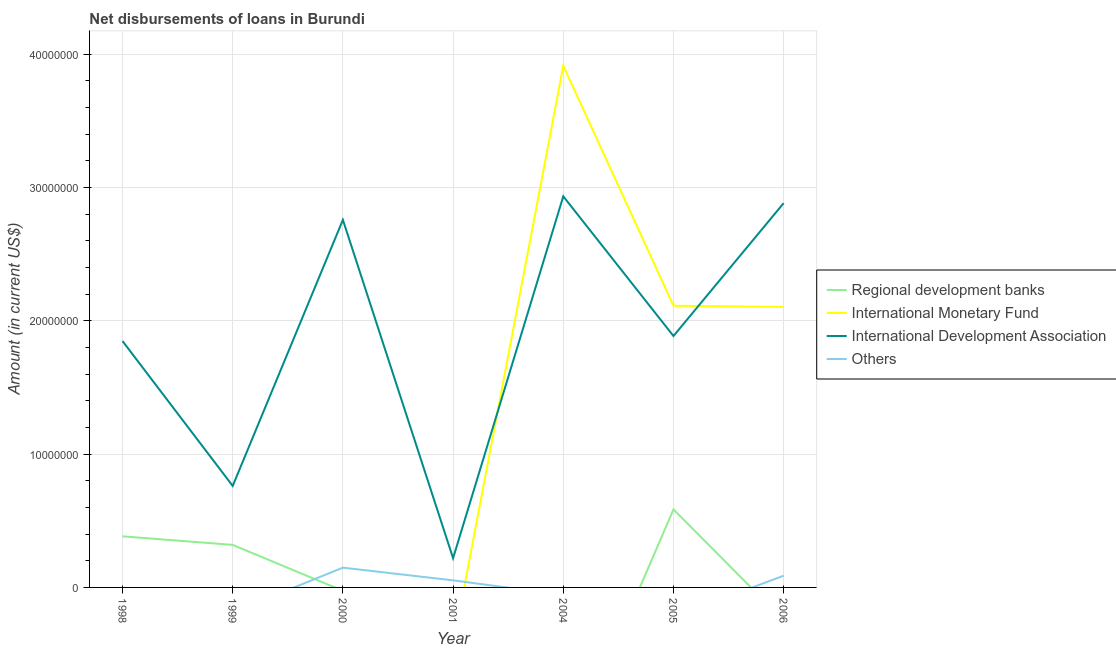How many different coloured lines are there?
Keep it short and to the point. 4. Across all years, what is the maximum amount of loan disimbursed by international monetary fund?
Your answer should be compact. 3.91e+07. Across all years, what is the minimum amount of loan disimbursed by international development association?
Give a very brief answer. 2.19e+06. What is the total amount of loan disimbursed by regional development banks in the graph?
Keep it short and to the point. 1.29e+07. What is the difference between the amount of loan disimbursed by international development association in 2005 and that in 2006?
Keep it short and to the point. -9.97e+06. What is the average amount of loan disimbursed by regional development banks per year?
Keep it short and to the point. 1.84e+06. In the year 1999, what is the difference between the amount of loan disimbursed by regional development banks and amount of loan disimbursed by international development association?
Your answer should be compact. -4.42e+06. In how many years, is the amount of loan disimbursed by other organisations greater than 12000000 US$?
Give a very brief answer. 0. What is the ratio of the amount of loan disimbursed by international development association in 1998 to that in 1999?
Provide a succinct answer. 2.43. What is the difference between the highest and the second highest amount of loan disimbursed by regional development banks?
Your response must be concise. 2.02e+06. What is the difference between the highest and the lowest amount of loan disimbursed by regional development banks?
Offer a terse response. 5.85e+06. Is it the case that in every year, the sum of the amount of loan disimbursed by regional development banks and amount of loan disimbursed by international monetary fund is greater than the amount of loan disimbursed by international development association?
Provide a succinct answer. No. Does the amount of loan disimbursed by regional development banks monotonically increase over the years?
Ensure brevity in your answer.  No. How many years are there in the graph?
Keep it short and to the point. 7. What is the difference between two consecutive major ticks on the Y-axis?
Ensure brevity in your answer.  1.00e+07. Does the graph contain any zero values?
Offer a terse response. Yes. How many legend labels are there?
Offer a terse response. 4. What is the title of the graph?
Your answer should be compact. Net disbursements of loans in Burundi. Does "Compensation of employees" appear as one of the legend labels in the graph?
Keep it short and to the point. No. What is the label or title of the Y-axis?
Ensure brevity in your answer.  Amount (in current US$). What is the Amount (in current US$) of Regional development banks in 1998?
Your response must be concise. 3.83e+06. What is the Amount (in current US$) in International Monetary Fund in 1998?
Your answer should be very brief. 0. What is the Amount (in current US$) in International Development Association in 1998?
Provide a short and direct response. 1.85e+07. What is the Amount (in current US$) in Others in 1998?
Your response must be concise. 0. What is the Amount (in current US$) in Regional development banks in 1999?
Keep it short and to the point. 3.19e+06. What is the Amount (in current US$) in International Monetary Fund in 1999?
Provide a short and direct response. 0. What is the Amount (in current US$) in International Development Association in 1999?
Keep it short and to the point. 7.61e+06. What is the Amount (in current US$) in Others in 1999?
Make the answer very short. 0. What is the Amount (in current US$) in Regional development banks in 2000?
Your answer should be very brief. 0. What is the Amount (in current US$) of International Monetary Fund in 2000?
Give a very brief answer. 0. What is the Amount (in current US$) in International Development Association in 2000?
Make the answer very short. 2.76e+07. What is the Amount (in current US$) of Others in 2000?
Provide a succinct answer. 1.48e+06. What is the Amount (in current US$) in International Monetary Fund in 2001?
Your answer should be compact. 0. What is the Amount (in current US$) in International Development Association in 2001?
Offer a very short reply. 2.19e+06. What is the Amount (in current US$) in Others in 2001?
Your answer should be compact. 5.31e+05. What is the Amount (in current US$) in Regional development banks in 2004?
Your answer should be compact. 0. What is the Amount (in current US$) in International Monetary Fund in 2004?
Provide a succinct answer. 3.91e+07. What is the Amount (in current US$) of International Development Association in 2004?
Make the answer very short. 2.93e+07. What is the Amount (in current US$) of Others in 2004?
Offer a very short reply. 0. What is the Amount (in current US$) of Regional development banks in 2005?
Make the answer very short. 5.85e+06. What is the Amount (in current US$) of International Monetary Fund in 2005?
Make the answer very short. 2.11e+07. What is the Amount (in current US$) of International Development Association in 2005?
Your answer should be very brief. 1.89e+07. What is the Amount (in current US$) of Regional development banks in 2006?
Provide a succinct answer. 0. What is the Amount (in current US$) in International Monetary Fund in 2006?
Keep it short and to the point. 2.10e+07. What is the Amount (in current US$) in International Development Association in 2006?
Provide a succinct answer. 2.88e+07. What is the Amount (in current US$) of Others in 2006?
Provide a short and direct response. 8.80e+05. Across all years, what is the maximum Amount (in current US$) of Regional development banks?
Your answer should be compact. 5.85e+06. Across all years, what is the maximum Amount (in current US$) in International Monetary Fund?
Your answer should be very brief. 3.91e+07. Across all years, what is the maximum Amount (in current US$) of International Development Association?
Provide a short and direct response. 2.93e+07. Across all years, what is the maximum Amount (in current US$) in Others?
Give a very brief answer. 1.48e+06. Across all years, what is the minimum Amount (in current US$) of Regional development banks?
Ensure brevity in your answer.  0. Across all years, what is the minimum Amount (in current US$) in International Monetary Fund?
Keep it short and to the point. 0. Across all years, what is the minimum Amount (in current US$) in International Development Association?
Provide a succinct answer. 2.19e+06. What is the total Amount (in current US$) of Regional development banks in the graph?
Provide a short and direct response. 1.29e+07. What is the total Amount (in current US$) of International Monetary Fund in the graph?
Give a very brief answer. 8.13e+07. What is the total Amount (in current US$) of International Development Association in the graph?
Give a very brief answer. 1.33e+08. What is the total Amount (in current US$) in Others in the graph?
Keep it short and to the point. 2.89e+06. What is the difference between the Amount (in current US$) in Regional development banks in 1998 and that in 1999?
Keep it short and to the point. 6.42e+05. What is the difference between the Amount (in current US$) in International Development Association in 1998 and that in 1999?
Your response must be concise. 1.09e+07. What is the difference between the Amount (in current US$) in International Development Association in 1998 and that in 2000?
Ensure brevity in your answer.  -9.09e+06. What is the difference between the Amount (in current US$) of International Development Association in 1998 and that in 2001?
Make the answer very short. 1.63e+07. What is the difference between the Amount (in current US$) of International Development Association in 1998 and that in 2004?
Give a very brief answer. -1.09e+07. What is the difference between the Amount (in current US$) in Regional development banks in 1998 and that in 2005?
Give a very brief answer. -2.02e+06. What is the difference between the Amount (in current US$) in International Development Association in 1998 and that in 2005?
Give a very brief answer. -3.78e+05. What is the difference between the Amount (in current US$) in International Development Association in 1998 and that in 2006?
Your answer should be very brief. -1.03e+07. What is the difference between the Amount (in current US$) of International Development Association in 1999 and that in 2000?
Provide a succinct answer. -2.00e+07. What is the difference between the Amount (in current US$) in International Development Association in 1999 and that in 2001?
Offer a terse response. 5.42e+06. What is the difference between the Amount (in current US$) in International Development Association in 1999 and that in 2004?
Keep it short and to the point. -2.17e+07. What is the difference between the Amount (in current US$) in Regional development banks in 1999 and that in 2005?
Keep it short and to the point. -2.66e+06. What is the difference between the Amount (in current US$) of International Development Association in 1999 and that in 2005?
Offer a terse response. -1.12e+07. What is the difference between the Amount (in current US$) of International Development Association in 1999 and that in 2006?
Offer a very short reply. -2.12e+07. What is the difference between the Amount (in current US$) of International Development Association in 2000 and that in 2001?
Your answer should be very brief. 2.54e+07. What is the difference between the Amount (in current US$) of Others in 2000 and that in 2001?
Give a very brief answer. 9.51e+05. What is the difference between the Amount (in current US$) in International Development Association in 2000 and that in 2004?
Offer a very short reply. -1.76e+06. What is the difference between the Amount (in current US$) in International Development Association in 2000 and that in 2005?
Your answer should be very brief. 8.71e+06. What is the difference between the Amount (in current US$) of International Development Association in 2000 and that in 2006?
Provide a succinct answer. -1.25e+06. What is the difference between the Amount (in current US$) in Others in 2000 and that in 2006?
Your answer should be very brief. 6.02e+05. What is the difference between the Amount (in current US$) of International Development Association in 2001 and that in 2004?
Offer a terse response. -2.71e+07. What is the difference between the Amount (in current US$) in International Development Association in 2001 and that in 2005?
Ensure brevity in your answer.  -1.67e+07. What is the difference between the Amount (in current US$) of International Development Association in 2001 and that in 2006?
Your answer should be compact. -2.66e+07. What is the difference between the Amount (in current US$) in Others in 2001 and that in 2006?
Make the answer very short. -3.49e+05. What is the difference between the Amount (in current US$) of International Monetary Fund in 2004 and that in 2005?
Give a very brief answer. 1.80e+07. What is the difference between the Amount (in current US$) of International Development Association in 2004 and that in 2005?
Your answer should be very brief. 1.05e+07. What is the difference between the Amount (in current US$) in International Monetary Fund in 2004 and that in 2006?
Your answer should be compact. 1.81e+07. What is the difference between the Amount (in current US$) of International Development Association in 2004 and that in 2006?
Your answer should be compact. 5.10e+05. What is the difference between the Amount (in current US$) in International Monetary Fund in 2005 and that in 2006?
Your answer should be compact. 8.50e+04. What is the difference between the Amount (in current US$) in International Development Association in 2005 and that in 2006?
Keep it short and to the point. -9.97e+06. What is the difference between the Amount (in current US$) in Regional development banks in 1998 and the Amount (in current US$) in International Development Association in 1999?
Provide a succinct answer. -3.78e+06. What is the difference between the Amount (in current US$) in Regional development banks in 1998 and the Amount (in current US$) in International Development Association in 2000?
Offer a very short reply. -2.37e+07. What is the difference between the Amount (in current US$) of Regional development banks in 1998 and the Amount (in current US$) of Others in 2000?
Offer a terse response. 2.35e+06. What is the difference between the Amount (in current US$) in International Development Association in 1998 and the Amount (in current US$) in Others in 2000?
Your answer should be compact. 1.70e+07. What is the difference between the Amount (in current US$) in Regional development banks in 1998 and the Amount (in current US$) in International Development Association in 2001?
Your answer should be very brief. 1.64e+06. What is the difference between the Amount (in current US$) in Regional development banks in 1998 and the Amount (in current US$) in Others in 2001?
Ensure brevity in your answer.  3.30e+06. What is the difference between the Amount (in current US$) in International Development Association in 1998 and the Amount (in current US$) in Others in 2001?
Your answer should be compact. 1.79e+07. What is the difference between the Amount (in current US$) in Regional development banks in 1998 and the Amount (in current US$) in International Monetary Fund in 2004?
Make the answer very short. -3.53e+07. What is the difference between the Amount (in current US$) in Regional development banks in 1998 and the Amount (in current US$) in International Development Association in 2004?
Keep it short and to the point. -2.55e+07. What is the difference between the Amount (in current US$) in Regional development banks in 1998 and the Amount (in current US$) in International Monetary Fund in 2005?
Your answer should be compact. -1.73e+07. What is the difference between the Amount (in current US$) in Regional development banks in 1998 and the Amount (in current US$) in International Development Association in 2005?
Offer a very short reply. -1.50e+07. What is the difference between the Amount (in current US$) in Regional development banks in 1998 and the Amount (in current US$) in International Monetary Fund in 2006?
Ensure brevity in your answer.  -1.72e+07. What is the difference between the Amount (in current US$) of Regional development banks in 1998 and the Amount (in current US$) of International Development Association in 2006?
Your response must be concise. -2.50e+07. What is the difference between the Amount (in current US$) of Regional development banks in 1998 and the Amount (in current US$) of Others in 2006?
Provide a short and direct response. 2.95e+06. What is the difference between the Amount (in current US$) in International Development Association in 1998 and the Amount (in current US$) in Others in 2006?
Provide a succinct answer. 1.76e+07. What is the difference between the Amount (in current US$) of Regional development banks in 1999 and the Amount (in current US$) of International Development Association in 2000?
Offer a terse response. -2.44e+07. What is the difference between the Amount (in current US$) of Regional development banks in 1999 and the Amount (in current US$) of Others in 2000?
Offer a very short reply. 1.71e+06. What is the difference between the Amount (in current US$) of International Development Association in 1999 and the Amount (in current US$) of Others in 2000?
Ensure brevity in your answer.  6.13e+06. What is the difference between the Amount (in current US$) in Regional development banks in 1999 and the Amount (in current US$) in International Development Association in 2001?
Provide a succinct answer. 9.99e+05. What is the difference between the Amount (in current US$) in Regional development banks in 1999 and the Amount (in current US$) in Others in 2001?
Your answer should be very brief. 2.66e+06. What is the difference between the Amount (in current US$) of International Development Association in 1999 and the Amount (in current US$) of Others in 2001?
Make the answer very short. 7.08e+06. What is the difference between the Amount (in current US$) of Regional development banks in 1999 and the Amount (in current US$) of International Monetary Fund in 2004?
Provide a short and direct response. -3.59e+07. What is the difference between the Amount (in current US$) in Regional development banks in 1999 and the Amount (in current US$) in International Development Association in 2004?
Give a very brief answer. -2.61e+07. What is the difference between the Amount (in current US$) of Regional development banks in 1999 and the Amount (in current US$) of International Monetary Fund in 2005?
Give a very brief answer. -1.79e+07. What is the difference between the Amount (in current US$) in Regional development banks in 1999 and the Amount (in current US$) in International Development Association in 2005?
Offer a very short reply. -1.57e+07. What is the difference between the Amount (in current US$) in Regional development banks in 1999 and the Amount (in current US$) in International Monetary Fund in 2006?
Give a very brief answer. -1.78e+07. What is the difference between the Amount (in current US$) in Regional development banks in 1999 and the Amount (in current US$) in International Development Association in 2006?
Make the answer very short. -2.56e+07. What is the difference between the Amount (in current US$) of Regional development banks in 1999 and the Amount (in current US$) of Others in 2006?
Give a very brief answer. 2.31e+06. What is the difference between the Amount (in current US$) of International Development Association in 1999 and the Amount (in current US$) of Others in 2006?
Ensure brevity in your answer.  6.73e+06. What is the difference between the Amount (in current US$) of International Development Association in 2000 and the Amount (in current US$) of Others in 2001?
Offer a terse response. 2.70e+07. What is the difference between the Amount (in current US$) in International Development Association in 2000 and the Amount (in current US$) in Others in 2006?
Ensure brevity in your answer.  2.67e+07. What is the difference between the Amount (in current US$) in International Development Association in 2001 and the Amount (in current US$) in Others in 2006?
Your answer should be compact. 1.31e+06. What is the difference between the Amount (in current US$) of International Monetary Fund in 2004 and the Amount (in current US$) of International Development Association in 2005?
Your response must be concise. 2.03e+07. What is the difference between the Amount (in current US$) of International Monetary Fund in 2004 and the Amount (in current US$) of International Development Association in 2006?
Your answer should be very brief. 1.03e+07. What is the difference between the Amount (in current US$) in International Monetary Fund in 2004 and the Amount (in current US$) in Others in 2006?
Make the answer very short. 3.82e+07. What is the difference between the Amount (in current US$) in International Development Association in 2004 and the Amount (in current US$) in Others in 2006?
Make the answer very short. 2.85e+07. What is the difference between the Amount (in current US$) in Regional development banks in 2005 and the Amount (in current US$) in International Monetary Fund in 2006?
Offer a terse response. -1.52e+07. What is the difference between the Amount (in current US$) in Regional development banks in 2005 and the Amount (in current US$) in International Development Association in 2006?
Give a very brief answer. -2.30e+07. What is the difference between the Amount (in current US$) in Regional development banks in 2005 and the Amount (in current US$) in Others in 2006?
Your answer should be compact. 4.97e+06. What is the difference between the Amount (in current US$) in International Monetary Fund in 2005 and the Amount (in current US$) in International Development Association in 2006?
Provide a short and direct response. -7.70e+06. What is the difference between the Amount (in current US$) in International Monetary Fund in 2005 and the Amount (in current US$) in Others in 2006?
Provide a succinct answer. 2.02e+07. What is the difference between the Amount (in current US$) in International Development Association in 2005 and the Amount (in current US$) in Others in 2006?
Keep it short and to the point. 1.80e+07. What is the average Amount (in current US$) in Regional development banks per year?
Provide a short and direct response. 1.84e+06. What is the average Amount (in current US$) of International Monetary Fund per year?
Your answer should be very brief. 1.16e+07. What is the average Amount (in current US$) of International Development Association per year?
Keep it short and to the point. 1.90e+07. What is the average Amount (in current US$) in Others per year?
Provide a short and direct response. 4.13e+05. In the year 1998, what is the difference between the Amount (in current US$) of Regional development banks and Amount (in current US$) of International Development Association?
Offer a very short reply. -1.46e+07. In the year 1999, what is the difference between the Amount (in current US$) in Regional development banks and Amount (in current US$) in International Development Association?
Make the answer very short. -4.42e+06. In the year 2000, what is the difference between the Amount (in current US$) of International Development Association and Amount (in current US$) of Others?
Make the answer very short. 2.61e+07. In the year 2001, what is the difference between the Amount (in current US$) in International Development Association and Amount (in current US$) in Others?
Your response must be concise. 1.66e+06. In the year 2004, what is the difference between the Amount (in current US$) in International Monetary Fund and Amount (in current US$) in International Development Association?
Provide a short and direct response. 9.79e+06. In the year 2005, what is the difference between the Amount (in current US$) of Regional development banks and Amount (in current US$) of International Monetary Fund?
Give a very brief answer. -1.53e+07. In the year 2005, what is the difference between the Amount (in current US$) of Regional development banks and Amount (in current US$) of International Development Association?
Provide a short and direct response. -1.30e+07. In the year 2005, what is the difference between the Amount (in current US$) of International Monetary Fund and Amount (in current US$) of International Development Association?
Provide a succinct answer. 2.27e+06. In the year 2006, what is the difference between the Amount (in current US$) in International Monetary Fund and Amount (in current US$) in International Development Association?
Your answer should be very brief. -7.78e+06. In the year 2006, what is the difference between the Amount (in current US$) in International Monetary Fund and Amount (in current US$) in Others?
Offer a terse response. 2.02e+07. In the year 2006, what is the difference between the Amount (in current US$) of International Development Association and Amount (in current US$) of Others?
Make the answer very short. 2.79e+07. What is the ratio of the Amount (in current US$) of Regional development banks in 1998 to that in 1999?
Keep it short and to the point. 1.2. What is the ratio of the Amount (in current US$) in International Development Association in 1998 to that in 1999?
Provide a succinct answer. 2.43. What is the ratio of the Amount (in current US$) of International Development Association in 1998 to that in 2000?
Provide a short and direct response. 0.67. What is the ratio of the Amount (in current US$) in International Development Association in 1998 to that in 2001?
Keep it short and to the point. 8.43. What is the ratio of the Amount (in current US$) of International Development Association in 1998 to that in 2004?
Your answer should be compact. 0.63. What is the ratio of the Amount (in current US$) of Regional development banks in 1998 to that in 2005?
Provide a succinct answer. 0.66. What is the ratio of the Amount (in current US$) of International Development Association in 1998 to that in 2006?
Keep it short and to the point. 0.64. What is the ratio of the Amount (in current US$) in International Development Association in 1999 to that in 2000?
Your answer should be compact. 0.28. What is the ratio of the Amount (in current US$) in International Development Association in 1999 to that in 2001?
Your response must be concise. 3.47. What is the ratio of the Amount (in current US$) of International Development Association in 1999 to that in 2004?
Make the answer very short. 0.26. What is the ratio of the Amount (in current US$) of Regional development banks in 1999 to that in 2005?
Provide a short and direct response. 0.55. What is the ratio of the Amount (in current US$) in International Development Association in 1999 to that in 2005?
Provide a succinct answer. 0.4. What is the ratio of the Amount (in current US$) of International Development Association in 1999 to that in 2006?
Your answer should be very brief. 0.26. What is the ratio of the Amount (in current US$) in International Development Association in 2000 to that in 2001?
Make the answer very short. 12.58. What is the ratio of the Amount (in current US$) in Others in 2000 to that in 2001?
Offer a terse response. 2.79. What is the ratio of the Amount (in current US$) in International Development Association in 2000 to that in 2004?
Offer a terse response. 0.94. What is the ratio of the Amount (in current US$) of International Development Association in 2000 to that in 2005?
Give a very brief answer. 1.46. What is the ratio of the Amount (in current US$) in International Development Association in 2000 to that in 2006?
Offer a terse response. 0.96. What is the ratio of the Amount (in current US$) in Others in 2000 to that in 2006?
Provide a succinct answer. 1.68. What is the ratio of the Amount (in current US$) in International Development Association in 2001 to that in 2004?
Your answer should be very brief. 0.07. What is the ratio of the Amount (in current US$) in International Development Association in 2001 to that in 2005?
Your answer should be very brief. 0.12. What is the ratio of the Amount (in current US$) of International Development Association in 2001 to that in 2006?
Provide a succinct answer. 0.08. What is the ratio of the Amount (in current US$) in Others in 2001 to that in 2006?
Give a very brief answer. 0.6. What is the ratio of the Amount (in current US$) of International Monetary Fund in 2004 to that in 2005?
Ensure brevity in your answer.  1.85. What is the ratio of the Amount (in current US$) of International Development Association in 2004 to that in 2005?
Your answer should be very brief. 1.56. What is the ratio of the Amount (in current US$) of International Monetary Fund in 2004 to that in 2006?
Your answer should be very brief. 1.86. What is the ratio of the Amount (in current US$) of International Development Association in 2004 to that in 2006?
Offer a very short reply. 1.02. What is the ratio of the Amount (in current US$) of International Monetary Fund in 2005 to that in 2006?
Offer a terse response. 1. What is the ratio of the Amount (in current US$) of International Development Association in 2005 to that in 2006?
Ensure brevity in your answer.  0.65. What is the difference between the highest and the second highest Amount (in current US$) in Regional development banks?
Keep it short and to the point. 2.02e+06. What is the difference between the highest and the second highest Amount (in current US$) of International Monetary Fund?
Make the answer very short. 1.80e+07. What is the difference between the highest and the second highest Amount (in current US$) of International Development Association?
Provide a succinct answer. 5.10e+05. What is the difference between the highest and the second highest Amount (in current US$) in Others?
Give a very brief answer. 6.02e+05. What is the difference between the highest and the lowest Amount (in current US$) in Regional development banks?
Make the answer very short. 5.85e+06. What is the difference between the highest and the lowest Amount (in current US$) of International Monetary Fund?
Provide a succinct answer. 3.91e+07. What is the difference between the highest and the lowest Amount (in current US$) of International Development Association?
Keep it short and to the point. 2.71e+07. What is the difference between the highest and the lowest Amount (in current US$) in Others?
Your answer should be compact. 1.48e+06. 